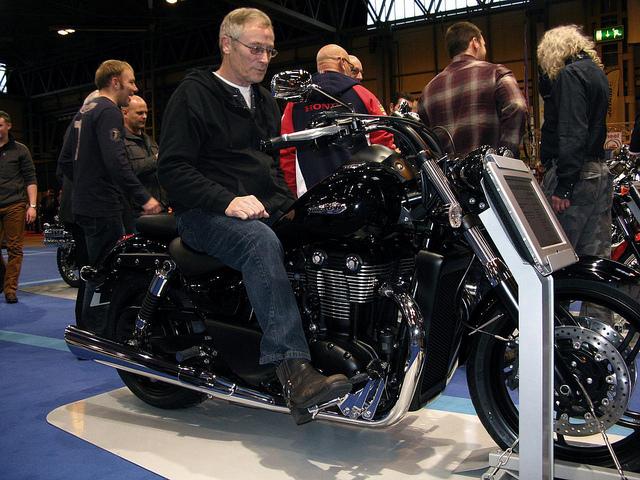Does the man on the motorcycle in the picture?
Write a very short answer. No. What is this person sitting on?
Write a very short answer. Motorcycle. Where is the man sitting?
Quick response, please. Motorcycle. 